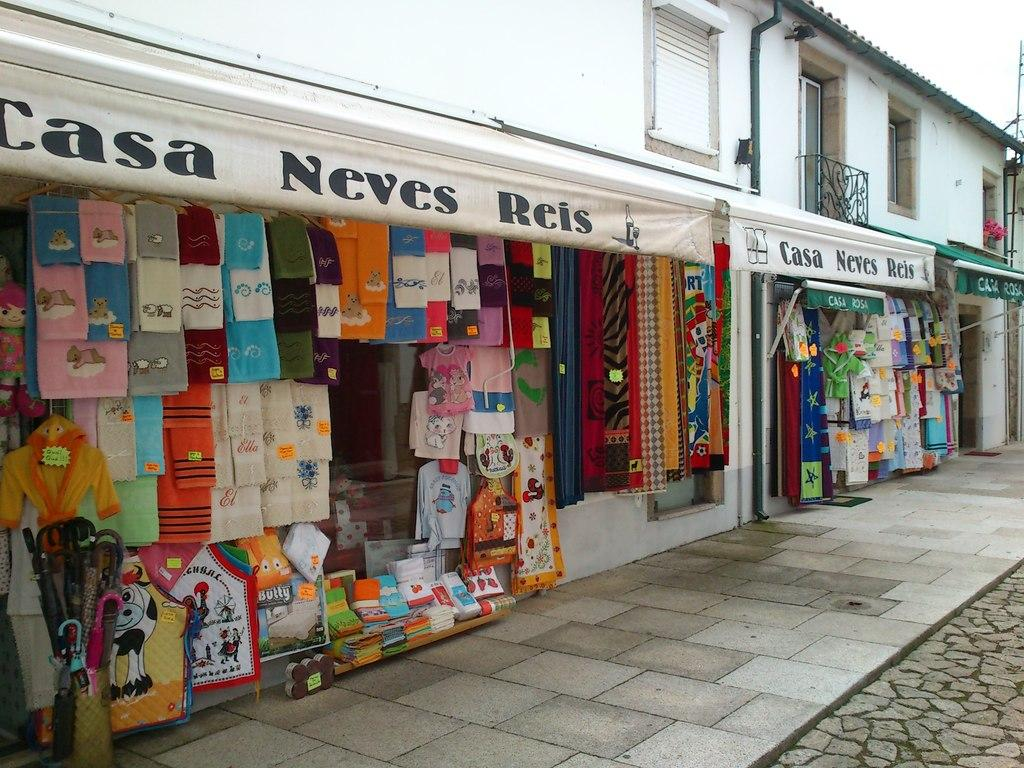<image>
Describe the image concisely. The storefront of Casa Neves Reis with items on display. 